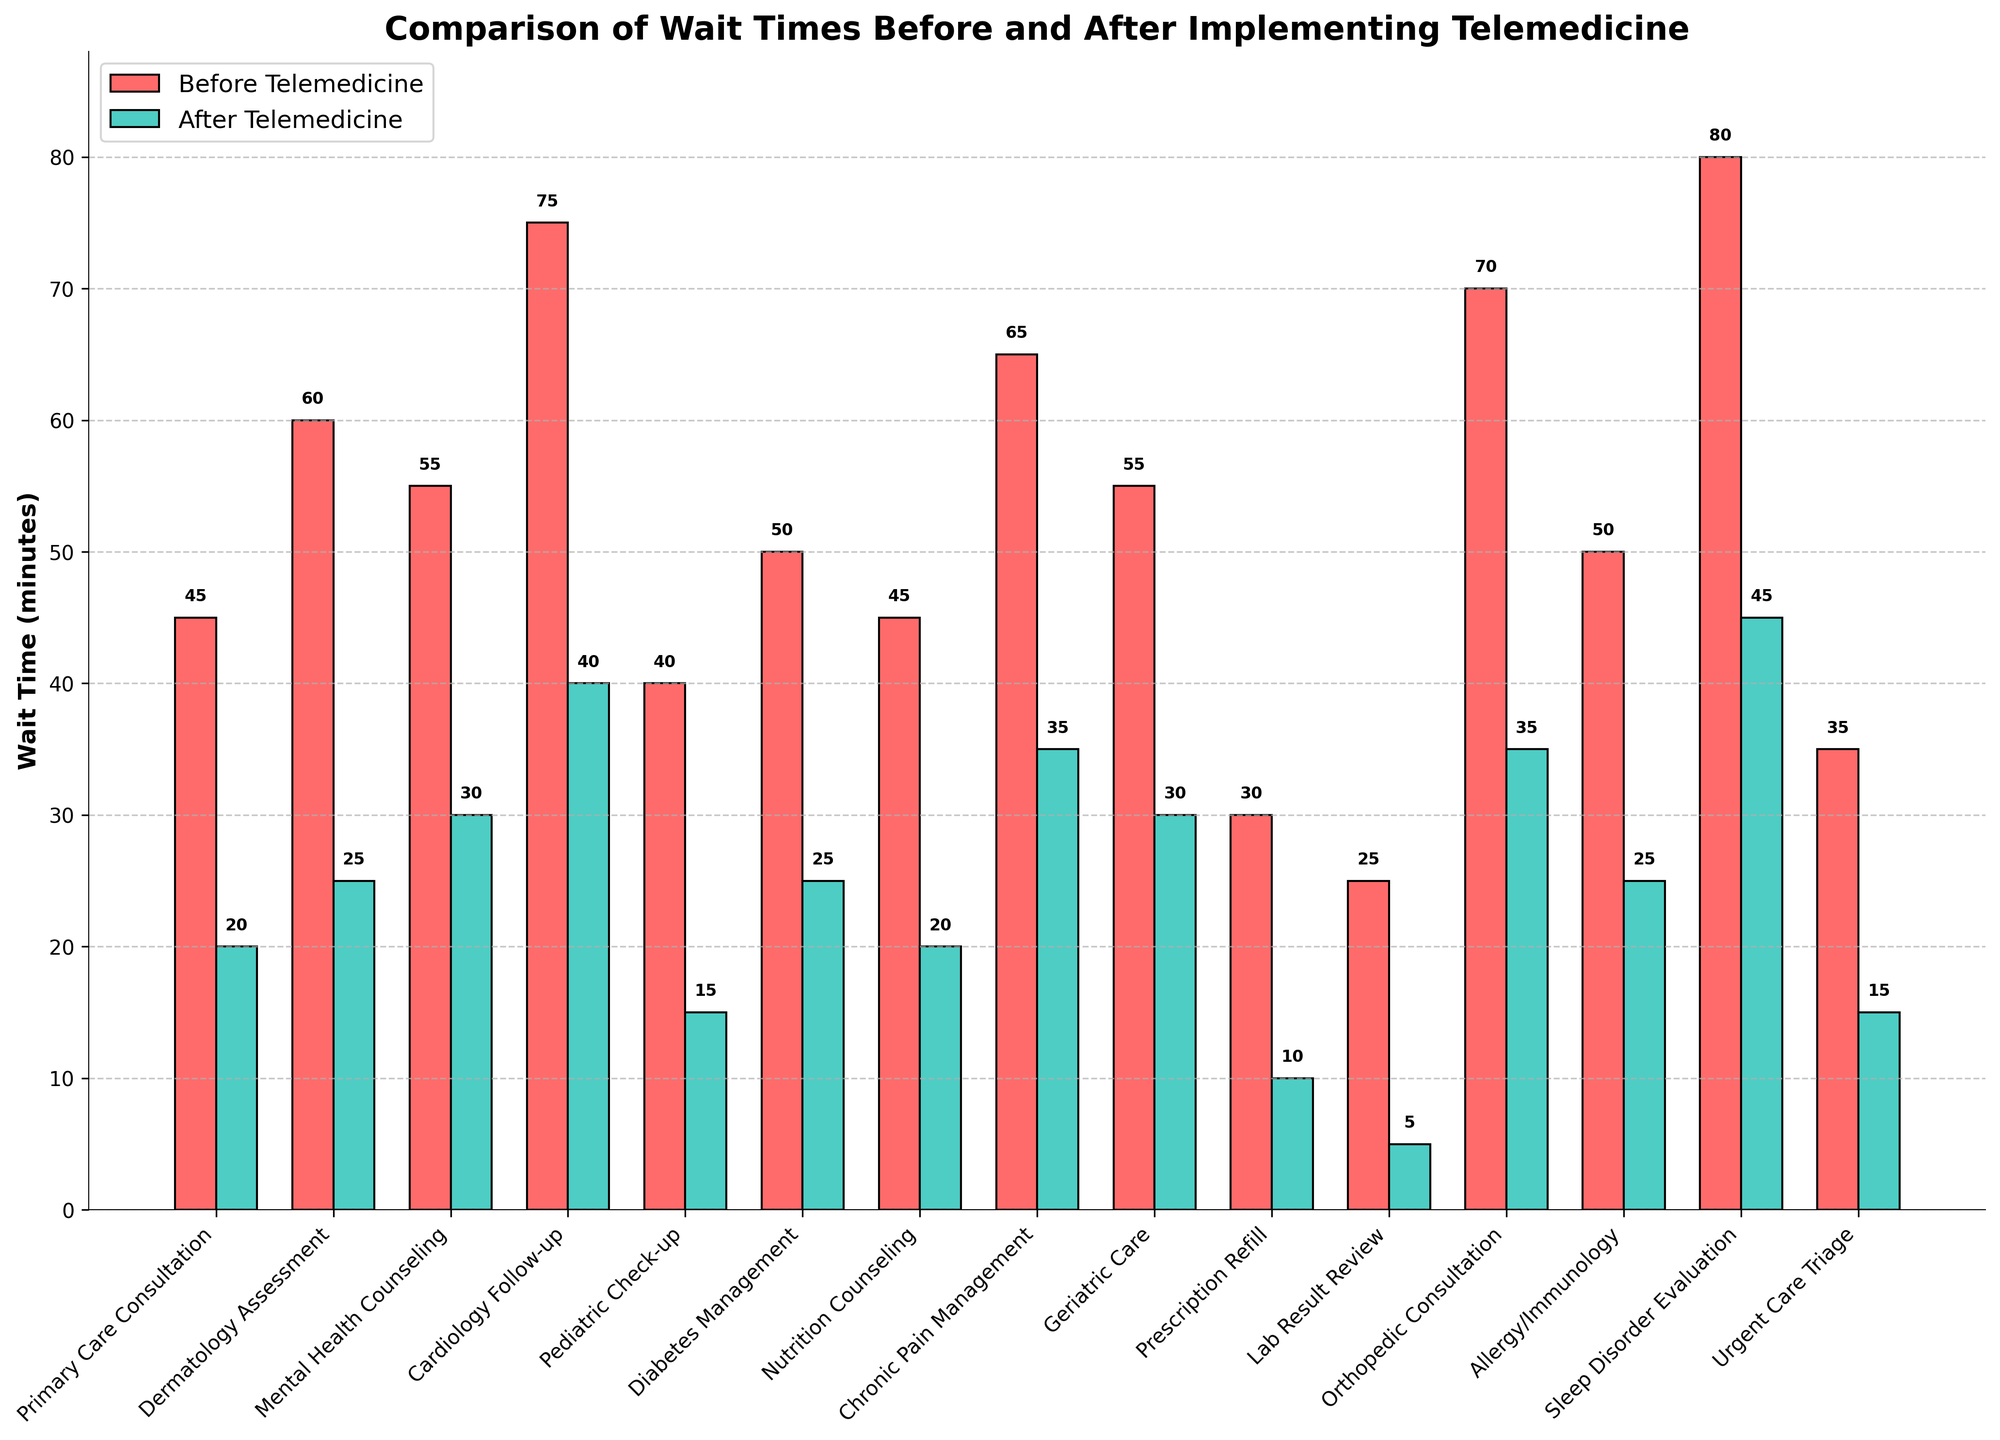Which service had the greatest reduction in wait time after implementing telemedicine? To find the service with the greatest reduction in wait time, calculate the difference between the "Before Telemedicine" and "After Telemedicine" for each service. The service with the largest positive difference is the one with the greatest reduction. The greatest reduction is seen in "Lab Result Review", which changed from 25 minutes to 5 minutes, a reduction of 20 minutes.
Answer: Lab Result Review Which service had the smallest reduction in wait time after implementing telemedicine? To determine the service with the smallest reduction in wait time, calculate the difference between "Before Telemedicine" and "After Telemedicine" for each service and identify the smallest positive value. The smallest reduction is seen in "Sleep Disorder Evaluation", which changed from 80 minutes to 45 minutes, a reduction of 35 minutes.
Answer: Sleep Disorder Evaluation What is the average wait time across all services after implementing telemedicine? To find the average wait time after implementing telemedicine, sum all the "After Telemedicine" values and divide by the number of services. The sum is 10 + 25 + 30 + 40 + 15 + 25 + 20 + 35 + 30 + 10 + 5 + 35 + 25 + 45 + 15 = 365 minutes. There are 15 services, so 365 / 15 = 24.33 minutes.
Answer: 24.33 minutes Which services had their wait times reduced by more than 50%? To determine which services had their wait times reduced by more than 50%, compare the "After Telemedicine" wait time to half of the "Before Telemedicine" wait time for each service. Services where "After Telemedicine" is less than half of "Before Telemedicine" are "Primary Care Consultation", "Pediatric Check-up", "Prescription Refill", and "Lab Result Review".
Answer: Primary Care Consultation, Pediatric Check-up, Prescription Refill, Lab Result Review Which service had the highest wait time before implementing telemedicine? To find the service with the highest wait time before implementing telemedicine, compare the "Before Telemedicine" values and identify the highest. "Sleep Disorder Evaluation" had the highest wait time at 80 minutes.
Answer: Sleep Disorder Evaluation By how many minutes did the wait time for "Cardiology Follow-up" reduce after implementing telemedicine? Calculate the reduction in wait time by subtracting the "After Telemedicine" value from the "Before Telemedicine" value for "Cardiology Follow-up". This results in 75 - 40 = 35 minutes.
Answer: 35 minutes Is the wait time after telemedicine implementation for "Dermatology Assessment" closer to the minimum or maximum wait time of all services? Identify the minimum and maximum "After Telemedicine" wait times (5 and 45 minutes, respectively). The wait time for "Dermatology Assessment" is 25 minutes, which lies closer to the maximum (45 minutes).
Answer: Closer to maximum What is the difference in average wait times before and after implementing telemedicine? First, calculate the average wait time before telemedicine by summing all "Before Telemedicine" values, then dividing by the number of services. The sum is 45 + 60 + 55 + 75 + 40 + 50 + 45 + 65 + 55 + 30 + 25 + 70 + 50 + 80 + 35 = 780 minutes. The average before telemedicine is 780 / 15 = 52 minutes. The average after telemedicine is previously calculated as 24.33 minutes. The difference is 52 - 24.33 = 27.67 minutes.
Answer: 27.67 minutes Which service had the same wait time reduced by 50% after implementing telemedicine? To find services with their wait time reduced by exactly 50%, compare the "After Telemedicine" wait time to half of the "Before Telemedicine" wait time for each service. "Orthopedic Consultation" reduced from 70 minutes to 35 minutes, a 50% reduction.
Answer: Orthopedic Consultation 